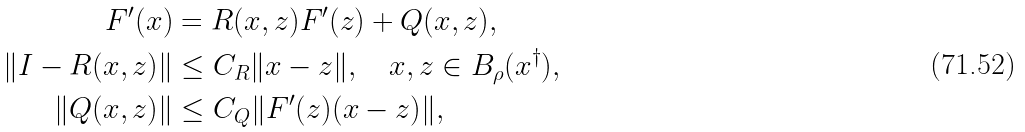<formula> <loc_0><loc_0><loc_500><loc_500>F ^ { \prime } ( x ) & = R ( x , z ) F ^ { \prime } ( z ) + Q ( x , z ) , \\ \| I - R ( x , z ) \| & \leq C _ { R } \| x - z \| , \quad x , z \in B _ { \rho } ( x ^ { \dag } ) , \\ \| Q ( x , z ) \| & \leq C _ { Q } \| F ^ { \prime } ( z ) ( x - z ) \| ,</formula> 